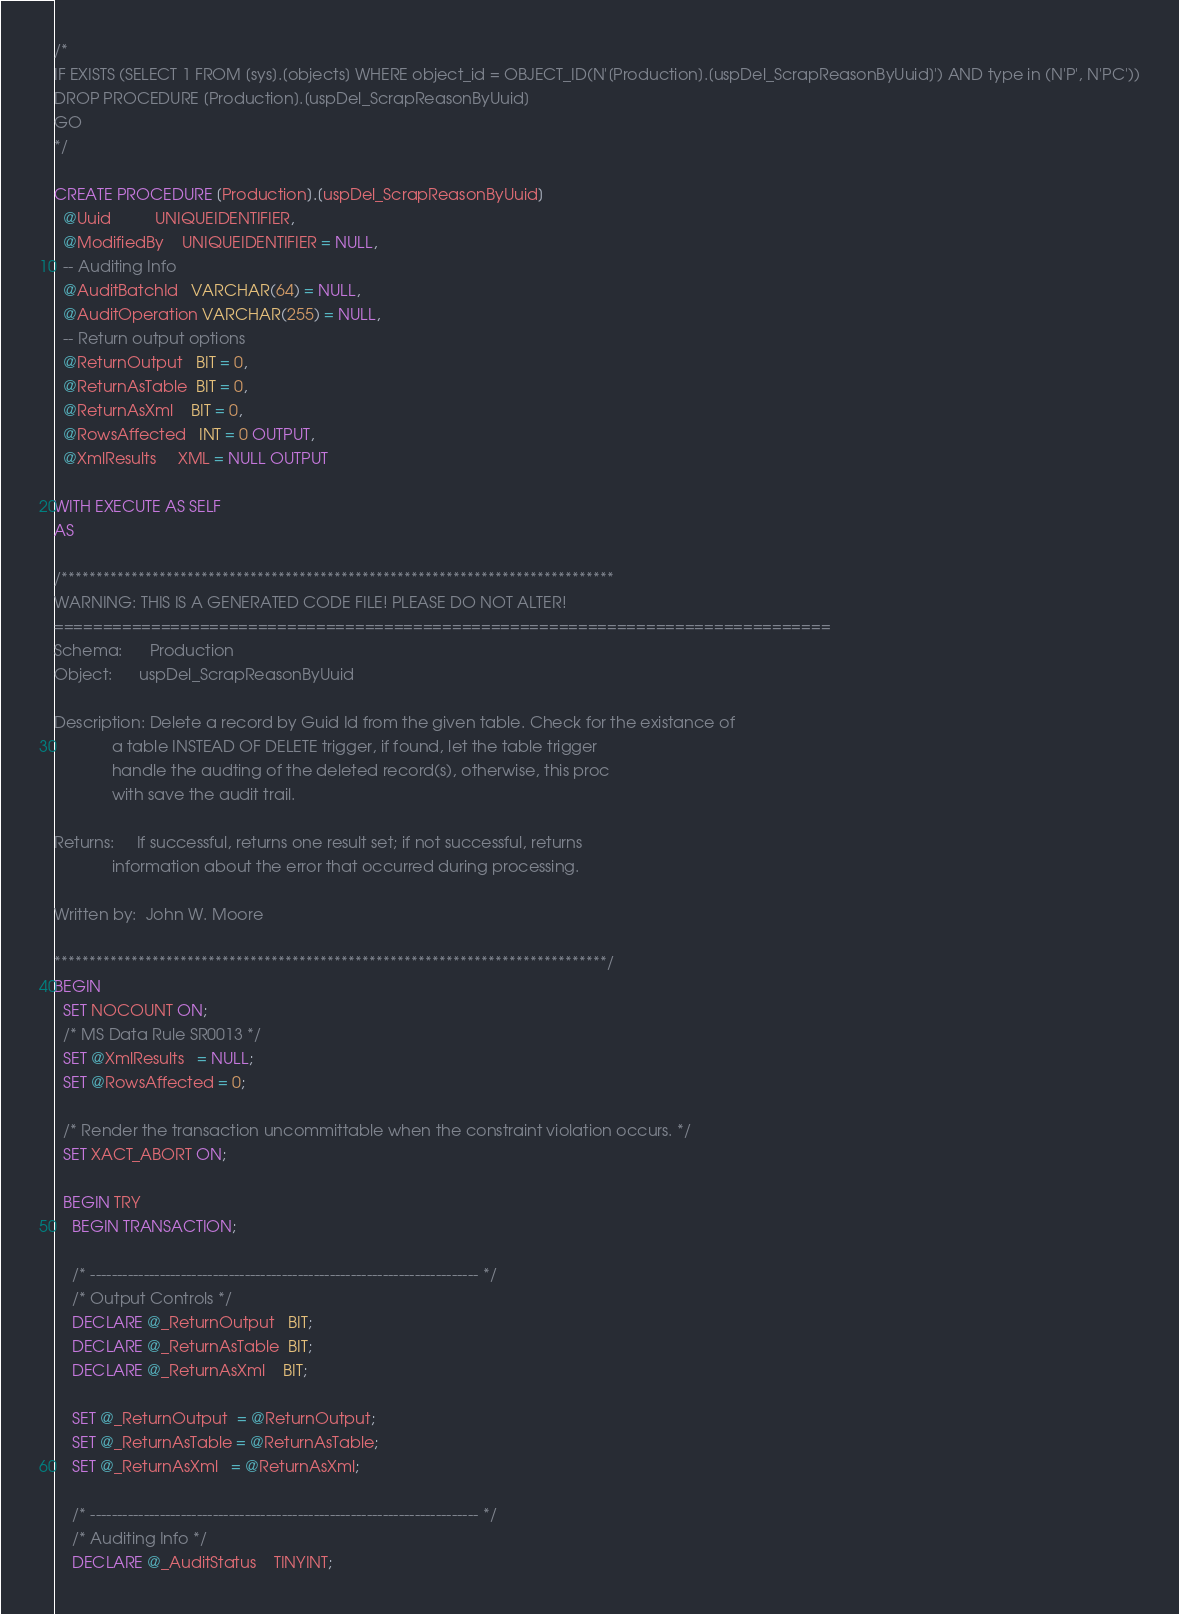Convert code to text. <code><loc_0><loc_0><loc_500><loc_500><_SQL_>/*
IF EXISTS (SELECT 1 FROM [sys].[objects] WHERE object_id = OBJECT_ID(N'[Production].[uspDel_ScrapReasonByUuid]') AND type in (N'P', N'PC'))
DROP PROCEDURE [Production].[uspDel_ScrapReasonByUuid]
GO
*/

CREATE PROCEDURE [Production].[uspDel_ScrapReasonByUuid]
  @Uuid          UNIQUEIDENTIFIER,
  @ModifiedBy    UNIQUEIDENTIFIER = NULL,
  -- Auditing Info
  @AuditBatchId   VARCHAR(64) = NULL,
  @AuditOperation VARCHAR(255) = NULL,
  -- Return output options
  @ReturnOutput   BIT = 0,
  @ReturnAsTable  BIT = 0,
  @ReturnAsXml    BIT = 0,
  @RowsAffected   INT = 0 OUTPUT,
  @XmlResults     XML = NULL OUTPUT

WITH EXECUTE AS SELF
AS

/*******************************************************************************
WARNING: THIS IS A GENERATED CODE FILE! PLEASE DO NOT ALTER!
================================================================================
Schema:      Production
Object:      uspDel_ScrapReasonByUuid

Description: Delete a record by Guid Id from the given table. Check for the existance of
             a table INSTEAD OF DELETE trigger, if found, let the table trigger
             handle the audting of the deleted record(s), otherwise, this proc
             with save the audit trail.

Returns:     If successful, returns one result set; if not successful, returns
             information about the error that occurred during processing.

Written by:  John W. Moore

*******************************************************************************/
BEGIN
  SET NOCOUNT ON;
  /* MS Data Rule SR0013 */
  SET @XmlResults   = NULL;
  SET @RowsAffected = 0;

  /* Render the transaction uncommittable when the constraint violation occurs. */
  SET XACT_ABORT ON;

  BEGIN TRY
    BEGIN TRANSACTION;

    /* ------------------------------------------------------------------------- */
    /* Output Controls */
    DECLARE @_ReturnOutput   BIT;
    DECLARE @_ReturnAsTable  BIT;
    DECLARE @_ReturnAsXml    BIT;

    SET @_ReturnOutput  = @ReturnOutput;
    SET @_ReturnAsTable = @ReturnAsTable;
    SET @_ReturnAsXml   = @ReturnAsXml;

    /* ------------------------------------------------------------------------- */
    /* Auditing Info */
    DECLARE @_AuditStatus    TINYINT;</code> 